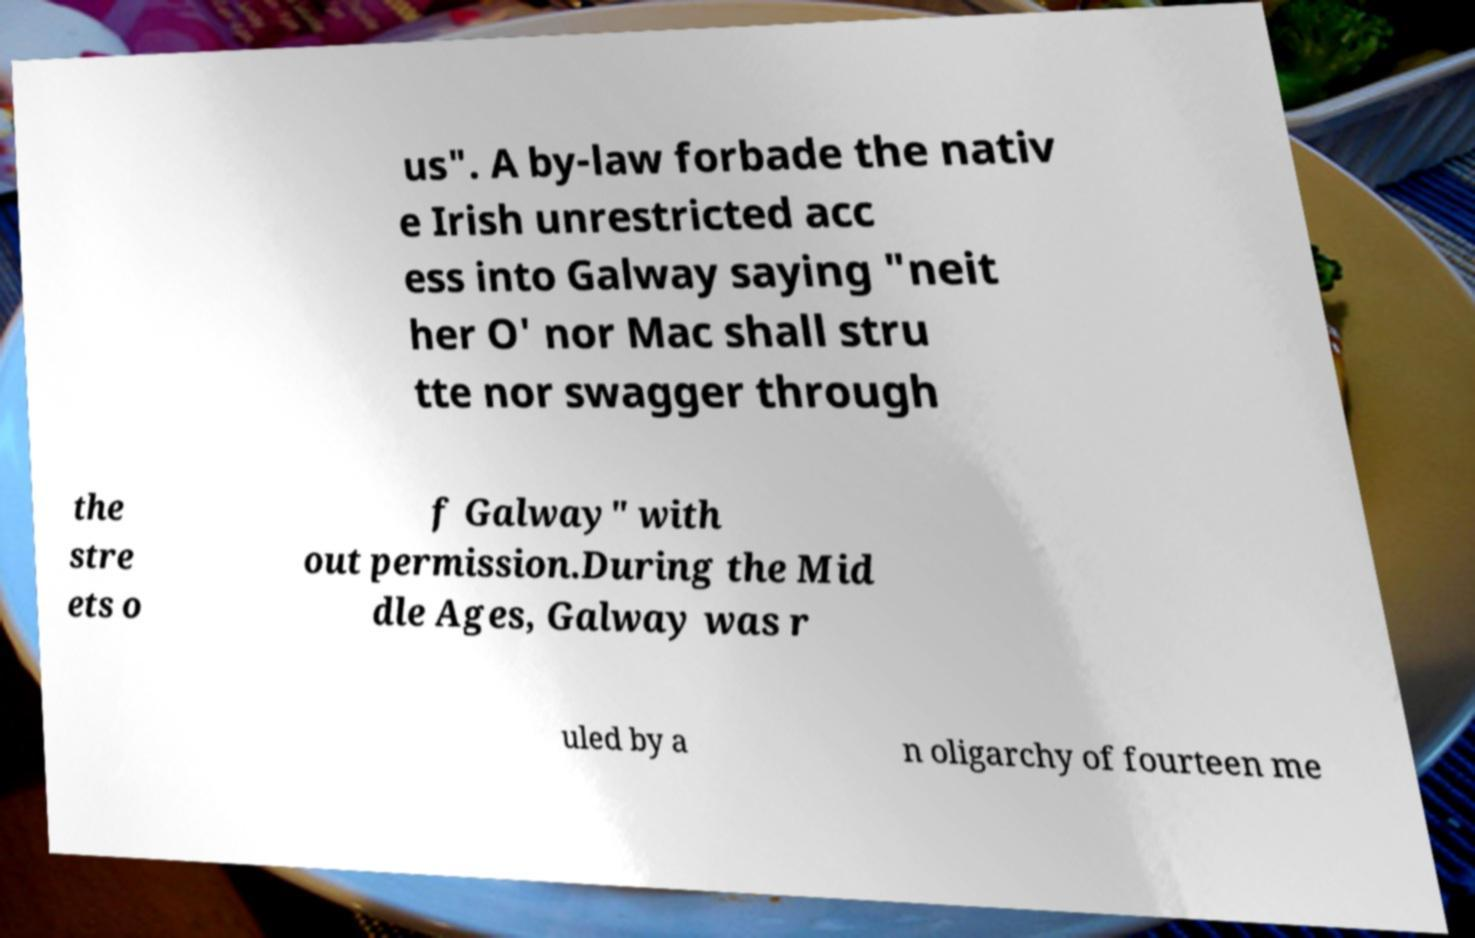There's text embedded in this image that I need extracted. Can you transcribe it verbatim? us". A by-law forbade the nativ e Irish unrestricted acc ess into Galway saying "neit her O' nor Mac shall stru tte nor swagger through the stre ets o f Galway" with out permission.During the Mid dle Ages, Galway was r uled by a n oligarchy of fourteen me 